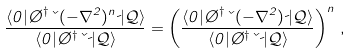Convert formula to latex. <formula><loc_0><loc_0><loc_500><loc_500>\frac { \langle 0 | \chi ^ { \dagger } \kappa ( - \nabla ^ { 2 } ) ^ { n } \psi | \mathcal { Q } \rangle } { \langle 0 | \chi ^ { \dagger } \kappa \psi | \mathcal { Q } \rangle } = \left ( \frac { \langle 0 | \chi ^ { \dagger } \kappa ( - \nabla ^ { 2 } ) \psi | \mathcal { Q } \rangle } { \langle 0 | \chi ^ { \dagger } \kappa \psi | \mathcal { Q } \rangle } \right ) ^ { n } \, ,</formula> 